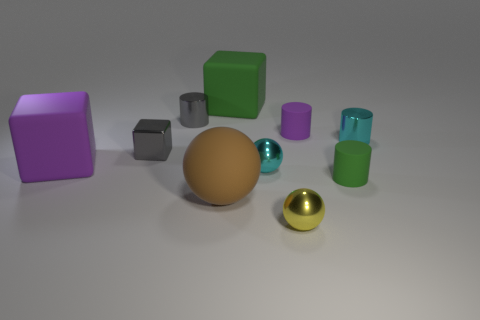What is the color of the object that is behind the tiny purple rubber object and in front of the large green object?
Your response must be concise. Gray. Does the purple thing to the right of the purple cube have the same size as the big purple rubber block?
Provide a short and direct response. No. Does the tiny cyan ball have the same material as the large cube that is in front of the tiny purple matte thing?
Make the answer very short. No. What number of red things are either tiny rubber cylinders or big spheres?
Provide a short and direct response. 0. Is there a blue shiny cube?
Keep it short and to the point. No. There is a small cyan metallic thing that is in front of the large rubber block that is in front of the tiny gray metallic block; are there any small cyan shiny cylinders that are left of it?
Provide a succinct answer. No. There is a small yellow metal thing; does it have the same shape as the tiny cyan object on the right side of the small yellow shiny object?
Provide a succinct answer. No. What color is the shiny thing on the right side of the small matte cylinder that is behind the cyan shiny object that is on the left side of the green cylinder?
Provide a succinct answer. Cyan. How many objects are either cylinders to the left of the small cyan cylinder or rubber things that are behind the brown thing?
Make the answer very short. 5. How many other things are there of the same color as the rubber sphere?
Ensure brevity in your answer.  0. 